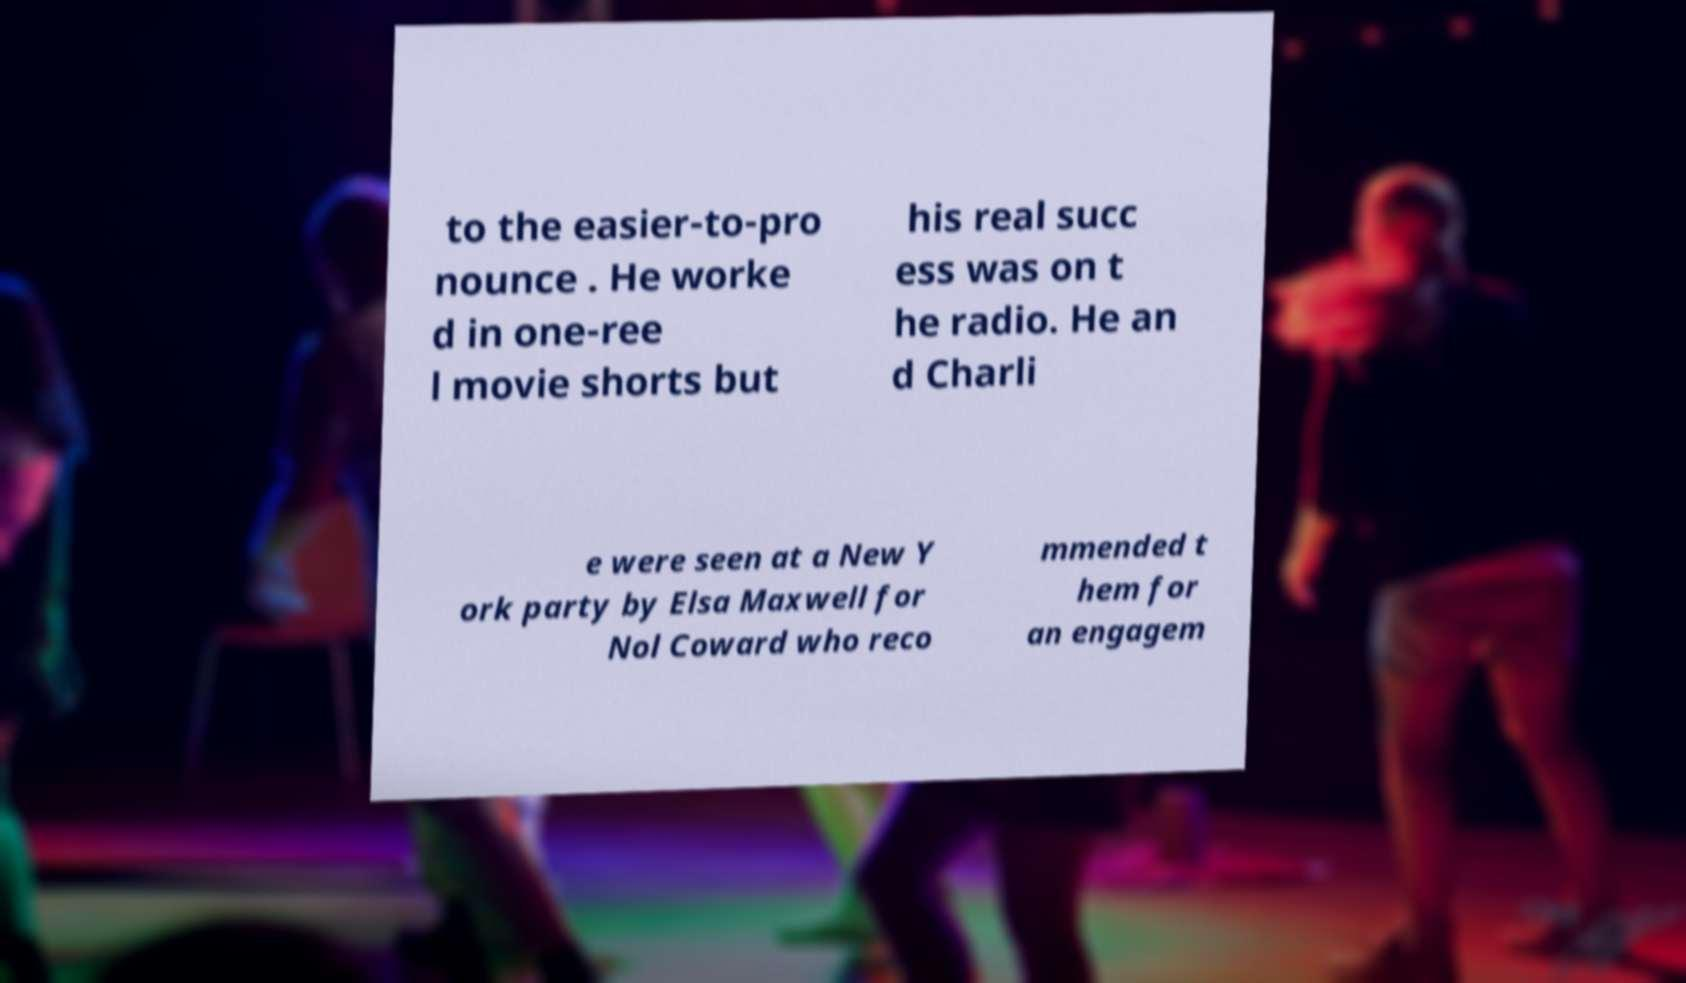Could you extract and type out the text from this image? to the easier-to-pro nounce . He worke d in one-ree l movie shorts but his real succ ess was on t he radio. He an d Charli e were seen at a New Y ork party by Elsa Maxwell for Nol Coward who reco mmended t hem for an engagem 